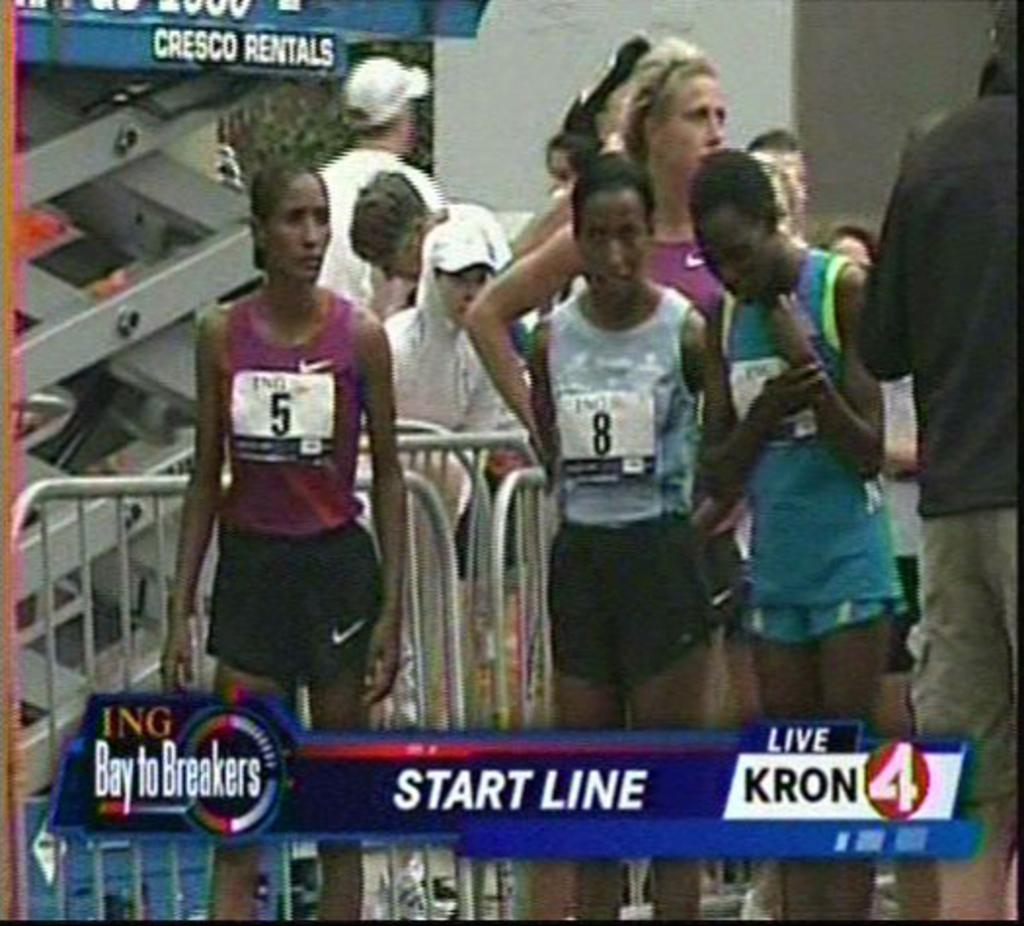What is attached to the persons in the image? There is a watermark attached to the persons in the image. Where are the people located in the image? The people are standing at the back of the image. What are the people holding in the image? The people are holding a metal grill. What word is written on the twig in the image? There is no twig or word present in the image. What statement can be made about the people's actions in the image? The image does not provide enough information to make a statement about the people's actions, as it only shows them standing and holding a metal grill. 